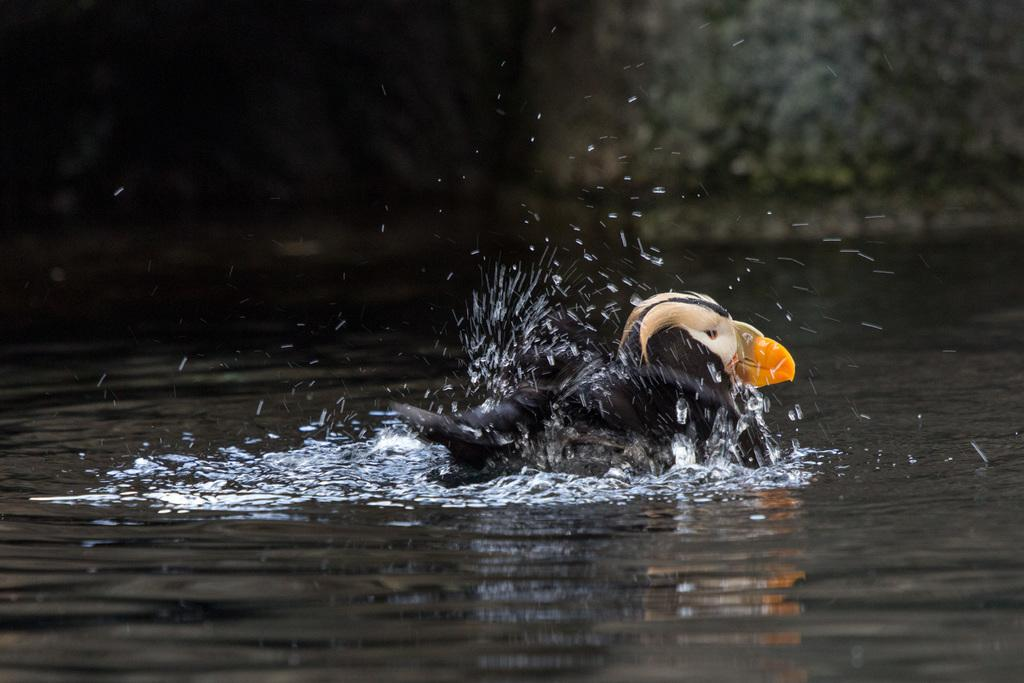What type of animal is in the image? There is a bird in the image. Where is the bird located in the image? The bird is on the water. Can you describe the background of the image? The background of the image is blurred. What type of stocking is the queen wearing in the image? There is no queen or stocking present in the image; it features a bird on the water. 